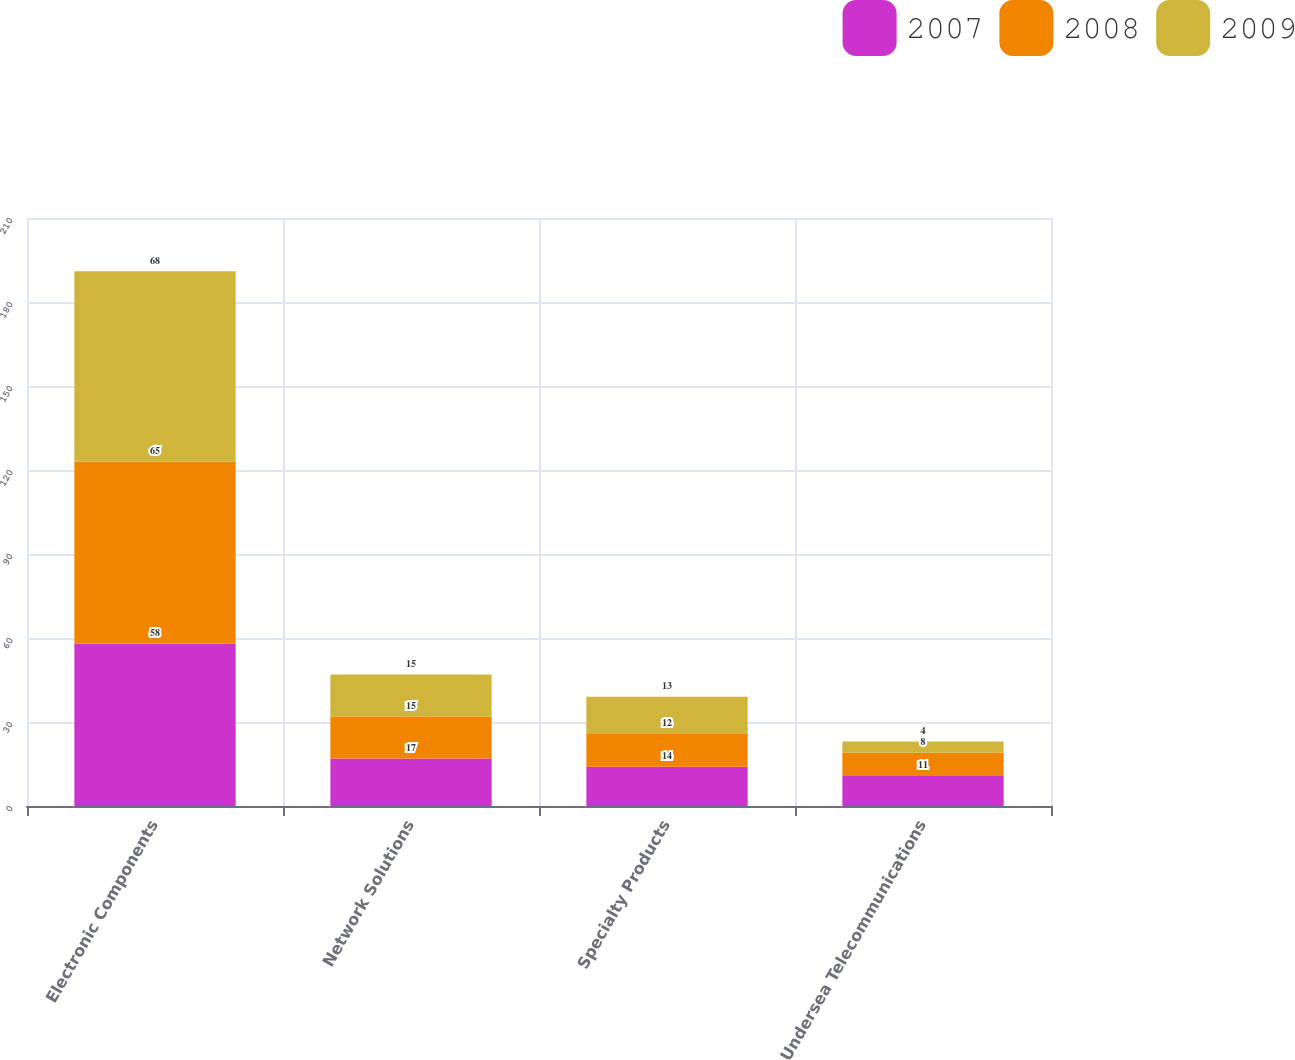Convert chart to OTSL. <chart><loc_0><loc_0><loc_500><loc_500><stacked_bar_chart><ecel><fcel>Electronic Components<fcel>Network Solutions<fcel>Specialty Products<fcel>Undersea Telecommunications<nl><fcel>2007<fcel>58<fcel>17<fcel>14<fcel>11<nl><fcel>2008<fcel>65<fcel>15<fcel>12<fcel>8<nl><fcel>2009<fcel>68<fcel>15<fcel>13<fcel>4<nl></chart> 